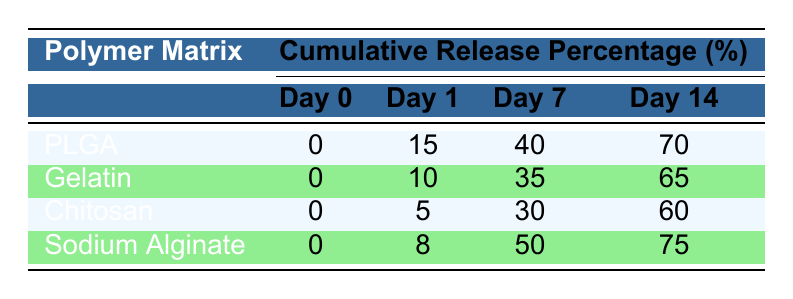What is the cumulative release percentage of Doxorubicin from PLGA at Day 7? The table shows that for PLGA, the cumulative release percentage of Doxorubicin at Day 7 is recorded as 40%.
Answer: 40 Which polymer matrix has the highest cumulative release percentage on Day 14? Reviewing the cumulative release percentages on Day 14, Sodium Alginate has 75%, which is higher than the other matrices: PLGA (70%), Gelatin (65%), and Chitosan (60%).
Answer: Sodium Alginate What is the cumulative release percentage difference between PLGA and Gelatin at Day 1? For PLGA at Day 1, the cumulative release percentage is 15%, while for Gelatin, it is 10%. The difference is calculated as 15% - 10% = 5%.
Answer: 5% Is the cumulative drug release from Chitosan higher or lower than that from Sodium Alginate at Day 1? At Day 1, Chitosan shows a cumulative release of 5%, while Sodium Alginate shows 8%. Therefore, Chitosan has lower release than Sodium Alginate.
Answer: Lower What is the average cumulative release percentage of Doxorubicin from all polymer matrices on Day 14? The cumulative percentages on Day 14 are 70% (PLGA), 65% (Gelatin), 60% (Chitosan), and 75% (Sodium Alginate). The total is 70 + 65 + 60 + 75 = 270, and there are 4 matrices, so the average is 270 / 4 = 67.5%.
Answer: 67.5% Which polymer matrix exhibits the least cumulative release percentage at Day 1? From the table, the cumulative release percentage at Day 1 for each matrix is: PLGA (15%), Gelatin (10%), Chitosan (5%), and Sodium Alginate (8%). Chitosan has the lowest at 5%.
Answer: Chitosan How much cumulative release percentage does Gelatin achieve from Day 1 to Day 14? For Gelatin, the cumulative percentages are 10% on Day 1 and 65% on Day 14. The increase is calculated as 65% - 10% = 55%.
Answer: 55% Which two polymer matrices show a cumulative release percentage of 60% at Day 14? By checking Day 14 data, PLGA shows 70%, Gelatin shows 65%, Chitosan shows 60%, and Sodium Alginate shows 75%. Only Chitosan reaches 60%, so it does not pair with any other matrix providing that percentage.
Answer: None 